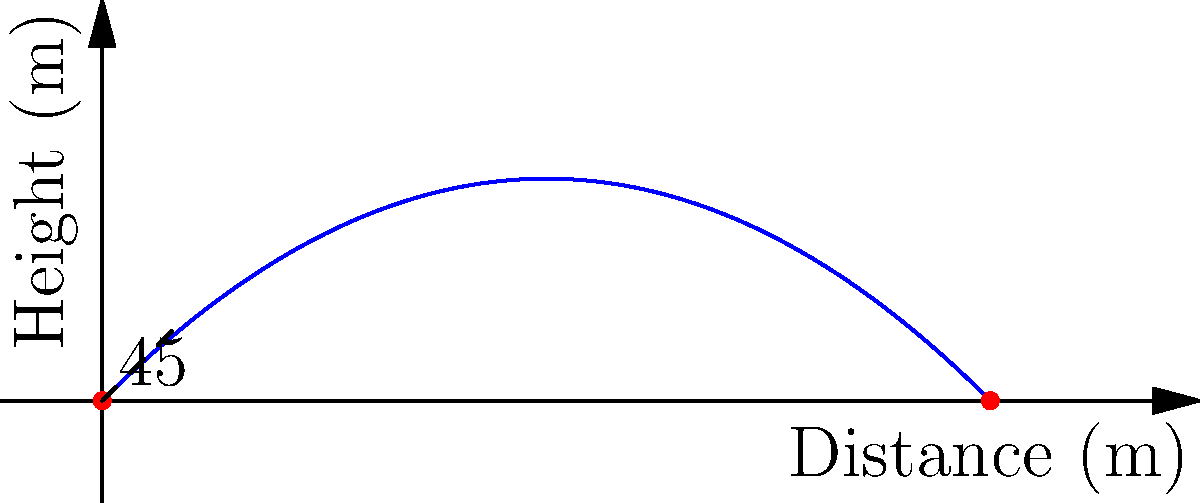In a crucial moment of a rugby match, you're tasked with a conversion kick. You kick the rugby ball with an initial velocity of 25 m/s at a 45-degree angle to the horizontal. Assuming no air resistance, what is the maximum height reached by the ball during its flight? To find the maximum height of the rugby ball's trajectory, we can follow these steps:

1) The vertical component of the initial velocity is:
   $v_{0y} = v_0 \sin(\theta) = 25 \cdot \sin(45°) = 25 \cdot \frac{\sqrt{2}}{2} \approx 17.68$ m/s

2) The time to reach the maximum height is when the vertical velocity becomes zero:
   $t_{max} = \frac{v_{0y}}{g} = \frac{17.68}{9.8} \approx 1.80$ s

3) The maximum height can be calculated using the equation:
   $h_{max} = v_{0y}t - \frac{1}{2}gt^2$

4) Substituting the values:
   $h_{max} = 17.68 \cdot 1.80 - \frac{1}{2} \cdot 9.8 \cdot 1.80^2$
   $h_{max} = 31.82 - 15.91 = 15.91$ m

Therefore, the maximum height reached by the rugby ball is approximately 15.91 meters.
Answer: 15.91 m 